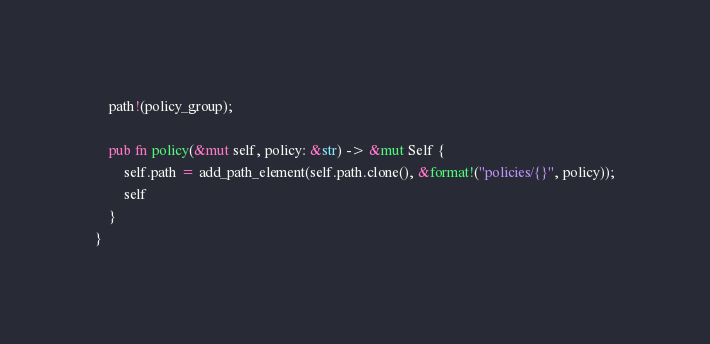Convert code to text. <code><loc_0><loc_0><loc_500><loc_500><_Rust_>    path!(policy_group);

    pub fn policy(&mut self, policy: &str) -> &mut Self {
        self.path = add_path_element(self.path.clone(), &format!("policies/{}", policy));
        self
    }
}
</code> 